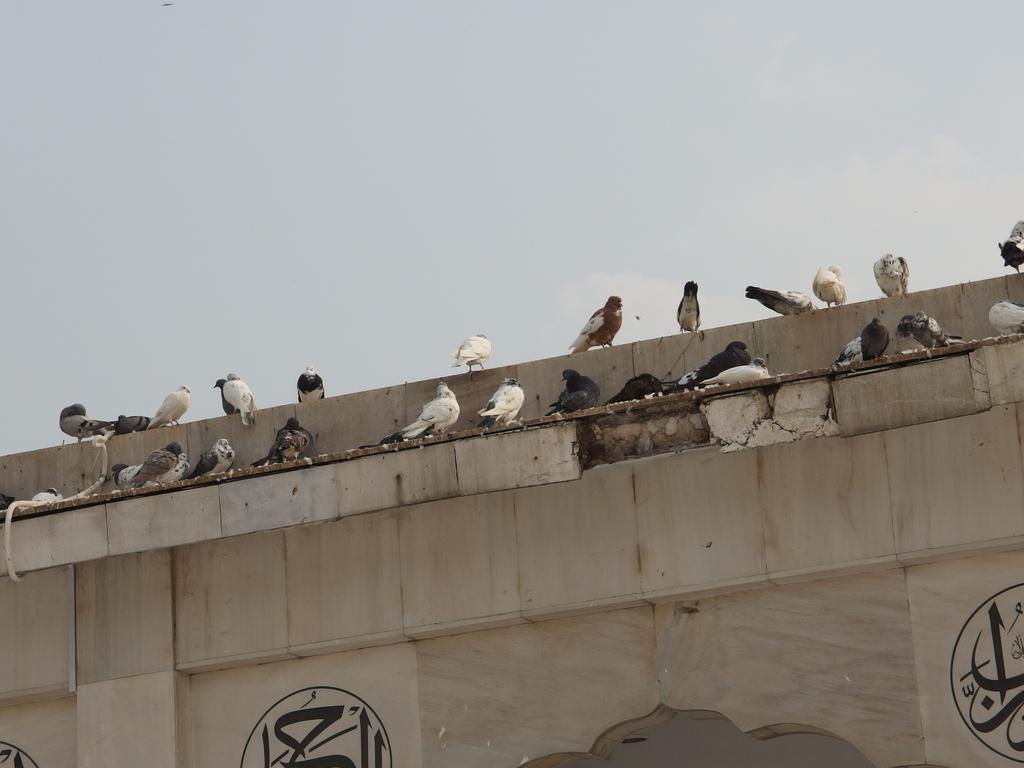What animals can be seen on the wall in the image? There are pigeons on a wall in the image. What else is present at the bottom of the wall in the image? There are paintings at the bottom of the wall in the image. What can be seen at the top of the image? The sky is visible at the top of the image. What trick do the pigeons perform in the image? There is no trick being performed by the pigeons in the image; they are simply perched on the wall. What is the size of the paintings at the bottom of the wall in the image? The size of the paintings cannot be determined from the image alone, as there is no reference for scale provided. 